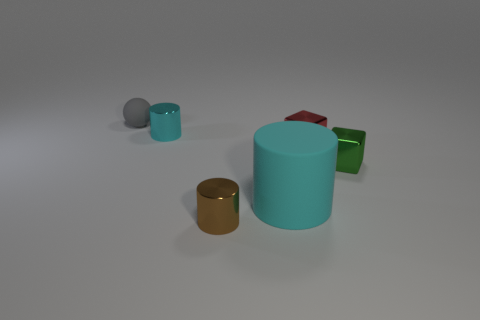Add 2 green metal cubes. How many objects exist? 8 Subtract all balls. How many objects are left? 5 Add 5 big cyan things. How many big cyan things exist? 6 Subtract 0 yellow blocks. How many objects are left? 6 Subtract all large brown shiny objects. Subtract all tiny gray things. How many objects are left? 5 Add 6 gray balls. How many gray balls are left? 7 